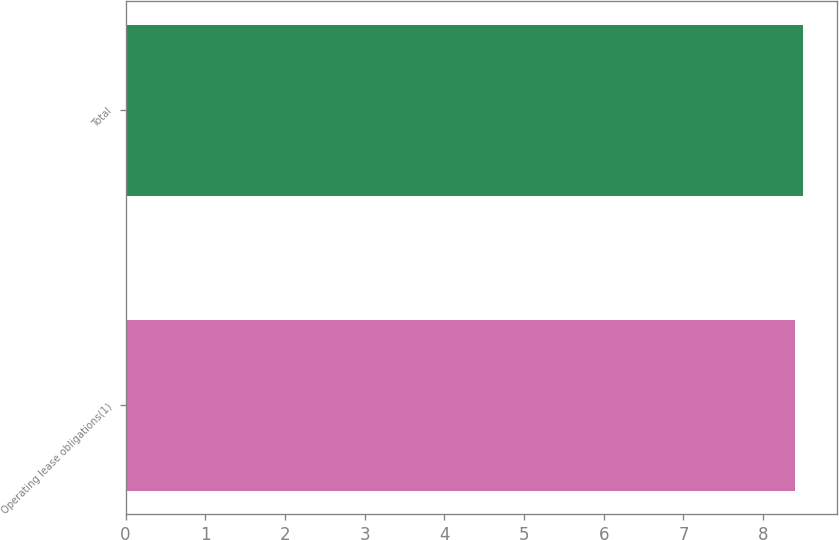Convert chart to OTSL. <chart><loc_0><loc_0><loc_500><loc_500><bar_chart><fcel>Operating lease obligations(1)<fcel>Total<nl><fcel>8.4<fcel>8.5<nl></chart> 